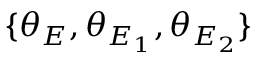Convert formula to latex. <formula><loc_0><loc_0><loc_500><loc_500>\{ \theta _ { E } , \theta _ { E _ { 1 } } , \theta _ { E _ { 2 } } \}</formula> 